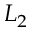<formula> <loc_0><loc_0><loc_500><loc_500>L _ { 2 }</formula> 